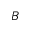<formula> <loc_0><loc_0><loc_500><loc_500>B</formula> 